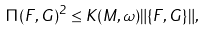<formula> <loc_0><loc_0><loc_500><loc_500>\Pi ( F , G ) ^ { 2 } \leq K ( M , \omega ) \| \{ F , G \} \| ,</formula> 